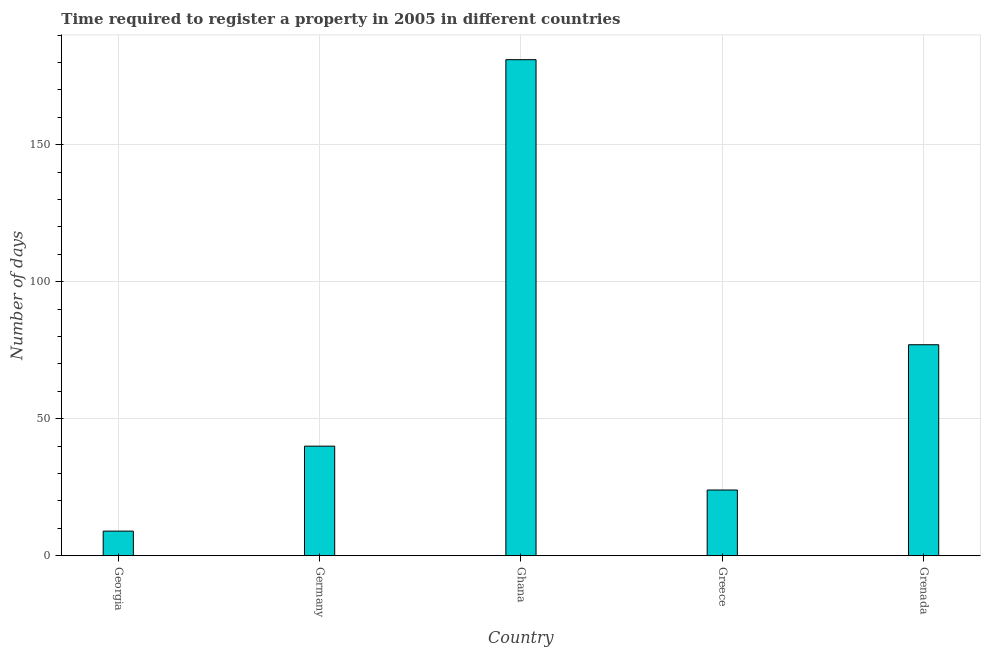What is the title of the graph?
Your answer should be compact. Time required to register a property in 2005 in different countries. What is the label or title of the X-axis?
Offer a very short reply. Country. What is the label or title of the Y-axis?
Your answer should be compact. Number of days. Across all countries, what is the maximum number of days required to register property?
Provide a succinct answer. 181. In which country was the number of days required to register property minimum?
Provide a succinct answer. Georgia. What is the sum of the number of days required to register property?
Make the answer very short. 331. What is the average number of days required to register property per country?
Give a very brief answer. 66.2. What is the ratio of the number of days required to register property in Germany to that in Greece?
Your answer should be compact. 1.67. Is the number of days required to register property in Germany less than that in Ghana?
Your answer should be compact. Yes. Is the difference between the number of days required to register property in Germany and Grenada greater than the difference between any two countries?
Your answer should be compact. No. What is the difference between the highest and the second highest number of days required to register property?
Provide a succinct answer. 104. What is the difference between the highest and the lowest number of days required to register property?
Provide a short and direct response. 172. In how many countries, is the number of days required to register property greater than the average number of days required to register property taken over all countries?
Provide a short and direct response. 2. How many bars are there?
Your response must be concise. 5. Are all the bars in the graph horizontal?
Provide a succinct answer. No. What is the Number of days of Ghana?
Ensure brevity in your answer.  181. What is the Number of days of Greece?
Your answer should be compact. 24. What is the Number of days of Grenada?
Provide a succinct answer. 77. What is the difference between the Number of days in Georgia and Germany?
Your answer should be compact. -31. What is the difference between the Number of days in Georgia and Ghana?
Give a very brief answer. -172. What is the difference between the Number of days in Georgia and Greece?
Your response must be concise. -15. What is the difference between the Number of days in Georgia and Grenada?
Your answer should be very brief. -68. What is the difference between the Number of days in Germany and Ghana?
Your answer should be compact. -141. What is the difference between the Number of days in Germany and Greece?
Provide a succinct answer. 16. What is the difference between the Number of days in Germany and Grenada?
Make the answer very short. -37. What is the difference between the Number of days in Ghana and Greece?
Your response must be concise. 157. What is the difference between the Number of days in Ghana and Grenada?
Keep it short and to the point. 104. What is the difference between the Number of days in Greece and Grenada?
Your response must be concise. -53. What is the ratio of the Number of days in Georgia to that in Germany?
Your answer should be very brief. 0.23. What is the ratio of the Number of days in Georgia to that in Ghana?
Provide a succinct answer. 0.05. What is the ratio of the Number of days in Georgia to that in Greece?
Ensure brevity in your answer.  0.38. What is the ratio of the Number of days in Georgia to that in Grenada?
Ensure brevity in your answer.  0.12. What is the ratio of the Number of days in Germany to that in Ghana?
Provide a succinct answer. 0.22. What is the ratio of the Number of days in Germany to that in Greece?
Provide a succinct answer. 1.67. What is the ratio of the Number of days in Germany to that in Grenada?
Keep it short and to the point. 0.52. What is the ratio of the Number of days in Ghana to that in Greece?
Give a very brief answer. 7.54. What is the ratio of the Number of days in Ghana to that in Grenada?
Offer a terse response. 2.35. What is the ratio of the Number of days in Greece to that in Grenada?
Your answer should be very brief. 0.31. 